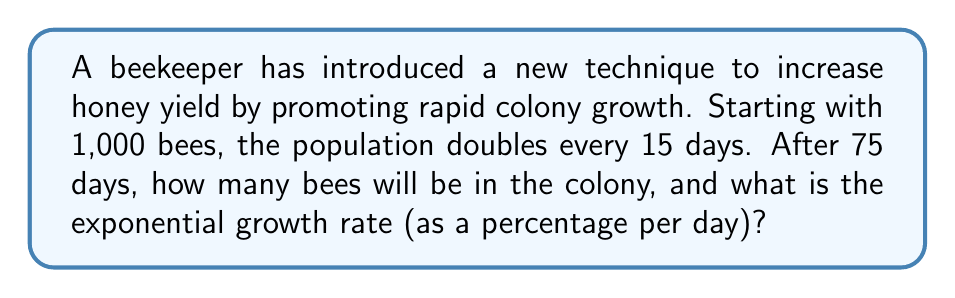Show me your answer to this math problem. To solve this problem, we'll follow these steps:

1. Calculate the number of times the population doubles:
   75 days ÷ 15 days per doubling = 5 doublings

2. Calculate the final population:
   Initial population: 1,000 bees
   After 5 doublings: $1000 \times 2^5 = 1000 \times 32 = 32,000$ bees

3. Calculate the exponential growth rate:
   Let $r$ be the daily growth rate.
   Over 75 days, the population grows by a factor of 32.
   We can express this as: $(1+r)^{75} = 32$

   Taking the natural logarithm of both sides:
   $75 \ln(1+r) = \ln(32)$

   Solving for $r$:
   $r = e^{\frac{\ln(32)}{75}} - 1$
   $r \approx 0.0462$ or 4.62% per day

To verify:
$1000 \times (1 + 0.0462)^{75} \approx 32,000$

Converting to a percentage: 4.62% per day
Answer: After 75 days, there will be 32,000 bees in the colony. The exponential growth rate is approximately 4.62% per day. 